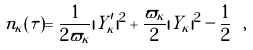Convert formula to latex. <formula><loc_0><loc_0><loc_500><loc_500>n _ { \kappa } ( \tau ) = \frac { 1 } { 2 \varpi _ { \kappa } } | Y _ { \kappa } ^ { \prime } | ^ { 2 } + \frac { \varpi _ { \kappa } } { 2 } | Y _ { \kappa } | ^ { 2 } - \frac { 1 } { 2 } \ ,</formula> 